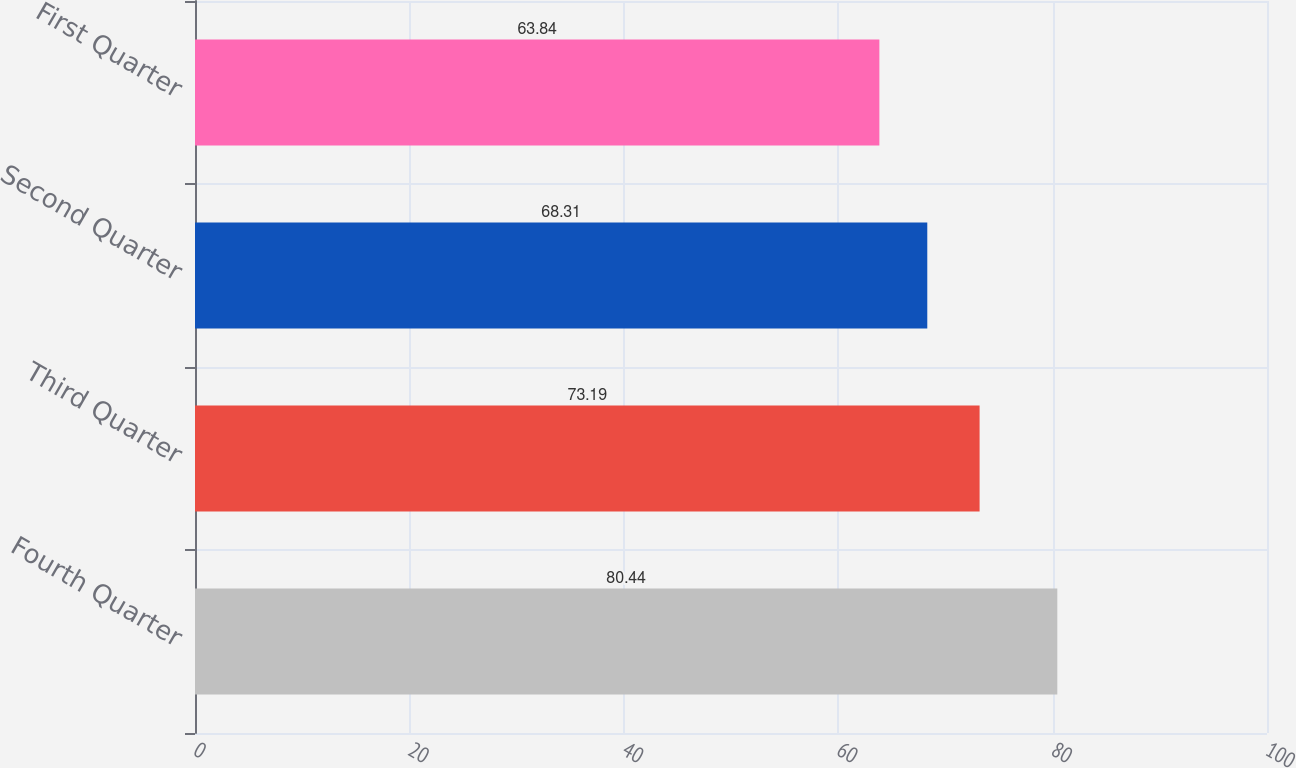<chart> <loc_0><loc_0><loc_500><loc_500><bar_chart><fcel>Fourth Quarter<fcel>Third Quarter<fcel>Second Quarter<fcel>First Quarter<nl><fcel>80.44<fcel>73.19<fcel>68.31<fcel>63.84<nl></chart> 